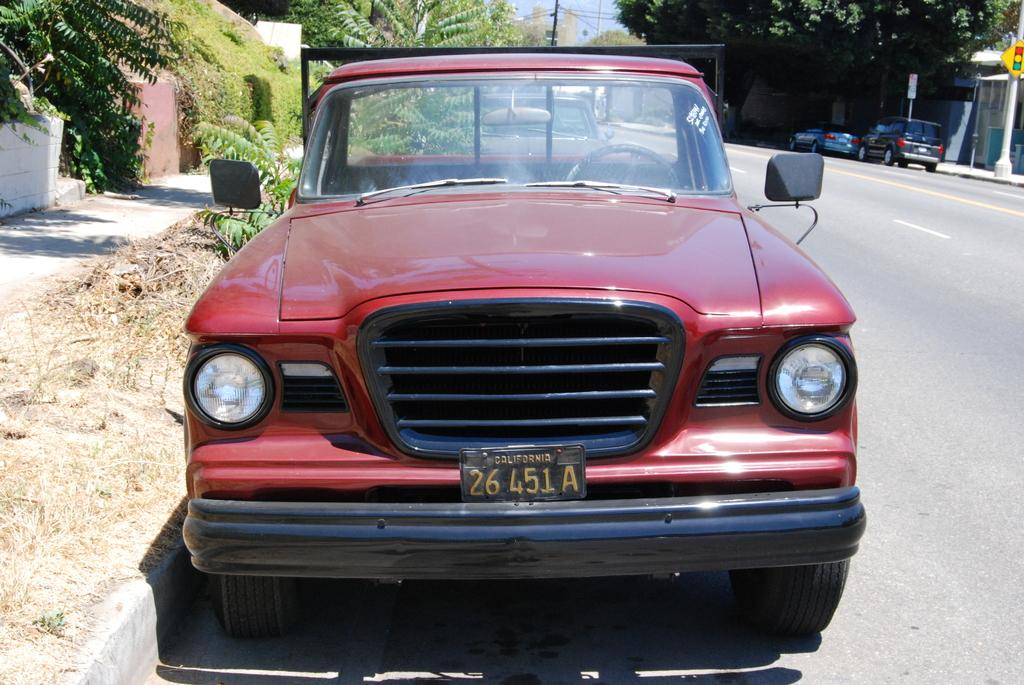What is the main subject of the image? There is a car in the image. Where is the car located? The car is on the road. What can be seen in the background of the image? There are buildings, trees, poles, vehicles, and the sky visible in the background of the image. What color are the eyes of the pen in the image? There is no pen present in the image, so it is not possible to determine the color of its eyes. 